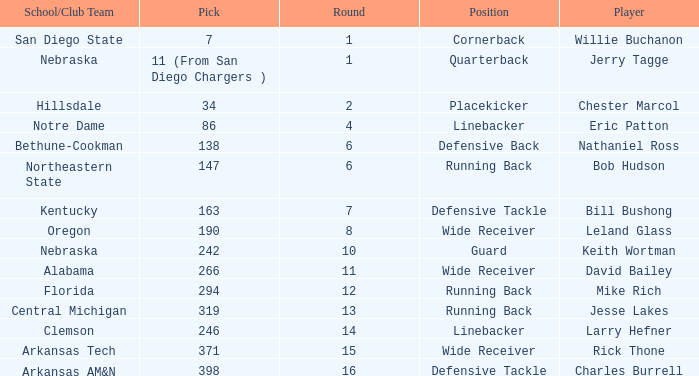I'm looking to parse the entire table for insights. Could you assist me with that? {'header': ['School/Club Team', 'Pick', 'Round', 'Position', 'Player'], 'rows': [['San Diego State', '7', '1', 'Cornerback', 'Willie Buchanon'], ['Nebraska', '11 (From San Diego Chargers )', '1', 'Quarterback', 'Jerry Tagge'], ['Hillsdale', '34', '2', 'Placekicker', 'Chester Marcol'], ['Notre Dame', '86', '4', 'Linebacker', 'Eric Patton'], ['Bethune-Cookman', '138', '6', 'Defensive Back', 'Nathaniel Ross'], ['Northeastern State', '147', '6', 'Running Back', 'Bob Hudson'], ['Kentucky', '163', '7', 'Defensive Tackle', 'Bill Bushong'], ['Oregon', '190', '8', 'Wide Receiver', 'Leland Glass'], ['Nebraska', '242', '10', 'Guard', 'Keith Wortman'], ['Alabama', '266', '11', 'Wide Receiver', 'David Bailey'], ['Florida', '294', '12', 'Running Back', 'Mike Rich'], ['Central Michigan', '319', '13', 'Running Back', 'Jesse Lakes'], ['Clemson', '246', '14', 'Linebacker', 'Larry Hefner'], ['Arkansas Tech', '371', '15', 'Wide Receiver', 'Rick Thone'], ['Arkansas AM&N', '398', '16', 'Defensive Tackle', 'Charles Burrell']]} Which pick has a school/club team that is kentucky? 163.0. 